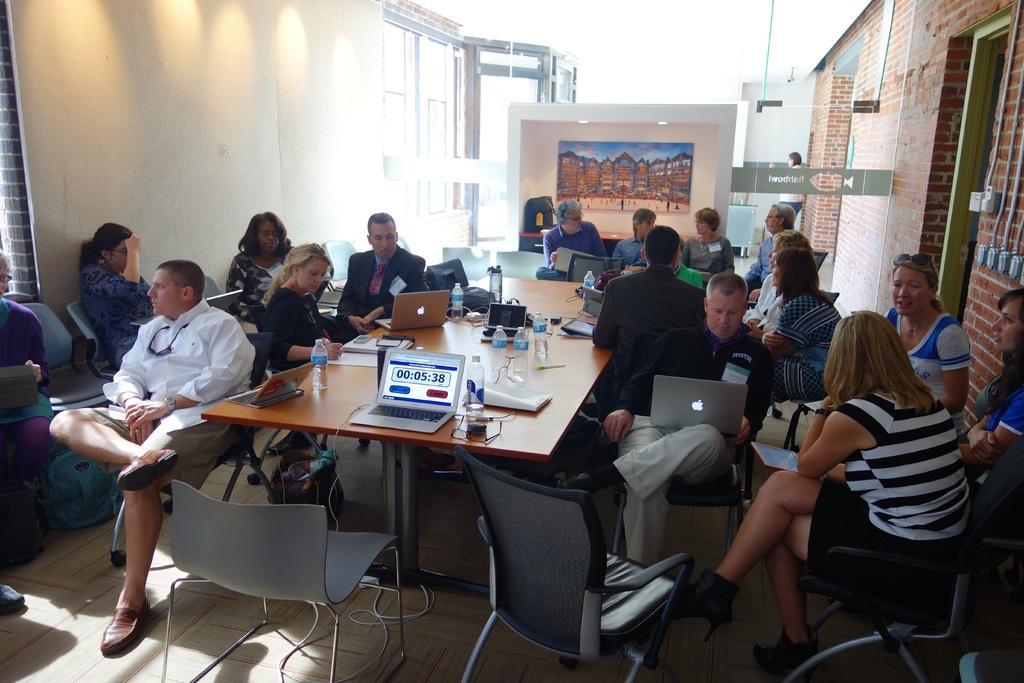Could you give a brief overview of what you see in this image? In this image there are group of people sitting in chairs with laptops and on table there are bottles, papers,bags, laptops and in back ground there is a frame, door, lights. 